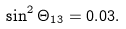<formula> <loc_0><loc_0><loc_500><loc_500>\sin ^ { 2 } { \Theta _ { 1 3 } } = 0 . 0 3 .</formula> 